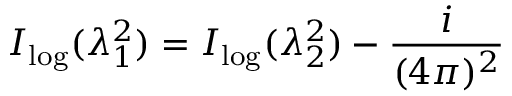Convert formula to latex. <formula><loc_0><loc_0><loc_500><loc_500>I _ { \log } ( \lambda _ { 1 } ^ { 2 } ) = I _ { \log } ( \lambda _ { 2 } ^ { 2 } ) - \frac { i } { ( 4 \pi ) ^ { 2 } }</formula> 